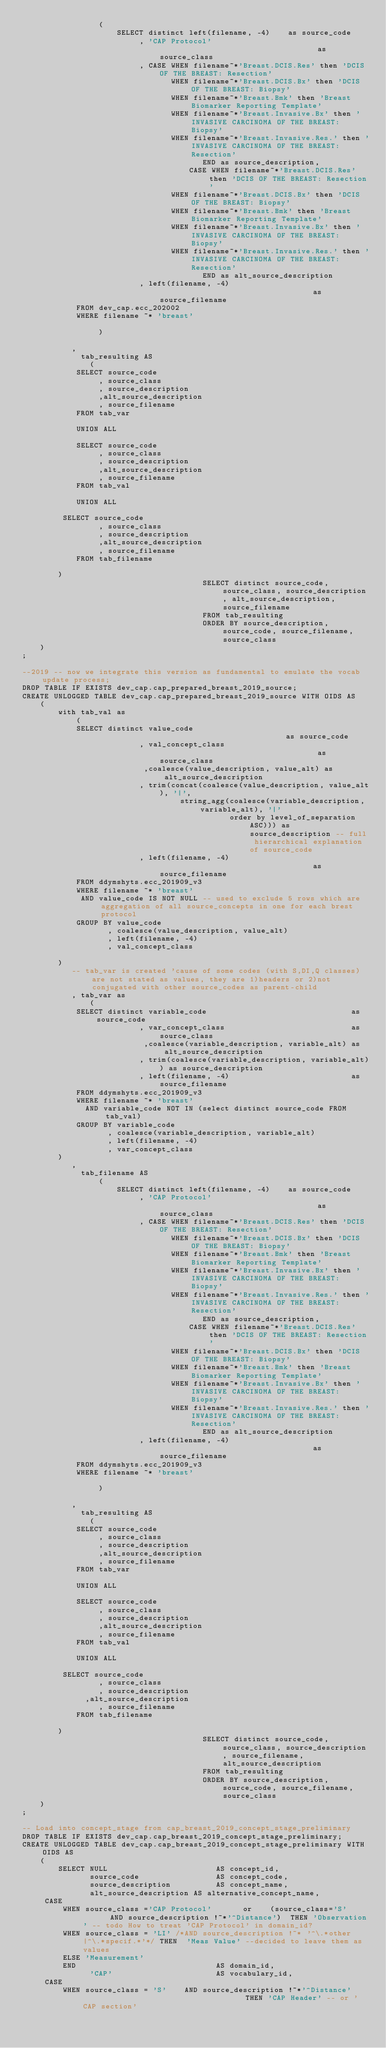Convert code to text. <code><loc_0><loc_0><loc_500><loc_500><_SQL_>                 (
                     SELECT distinct left(filename, -4)    as source_code
                          , 'CAP Protocol'                                    as source_class
                          , CASE WHEN filename~*'Breast.DCIS.Res' then 'DCIS OF THE BREAST: Resection'
                                 WHEN filename~*'Breast.DCIS.Bx' then 'DCIS OF THE BREAST: Biopsy'
                                 WHEN filename~*'Breast.Bmk' then 'Breast Biomarker Reporting Template'
                                 WHEN filename~*'Breast.Invasive.Bx' then 'INVASIVE CARCINOMA OF THE BREAST: Biopsy'
                                 WHEN filename~*'Breast.Invasive.Res.' then 'INVASIVE CARCINOMA OF THE BREAST: Resection'
                                        END as source_description,
                                     CASE WHEN filename~*'Breast.DCIS.Res' then 'DCIS OF THE BREAST: Resection'
                                 WHEN filename~*'Breast.DCIS.Bx' then 'DCIS OF THE BREAST: Biopsy'
                                 WHEN filename~*'Breast.Bmk' then 'Breast Biomarker Reporting Template'
                                 WHEN filename~*'Breast.Invasive.Bx' then 'INVASIVE CARCINOMA OF THE BREAST: Biopsy'
                                 WHEN filename~*'Breast.Invasive.Res.' then 'INVASIVE CARCINOMA OF THE BREAST: Resection'
                                        END as alt_source_description
                          , left(filename, -4)                                   as source_filename
            FROM dev_cap.ecc_202002
            WHERE filename ~* 'breast'

                 )

           ,
             tab_resulting AS
               (
            SELECT source_code
                 , source_class
                 , source_description
                 ,alt_source_description
                 , source_filename
            FROM tab_var

            UNION ALL

            SELECT source_code
                 , source_class
                 , source_description
                 ,alt_source_description
                 , source_filename
            FROM tab_val

            UNION ALL

         SELECT source_code
                 , source_class
                 , source_description
                 ,alt_source_description
                 , source_filename
            FROM tab_filename

        )
                                        SELECT distinct source_code, source_class, source_description, alt_source_description, source_filename
                                        FROM tab_resulting
                                        ORDER BY source_description, source_code, source_filename, source_class
    )
;

--2019 -- now we integrate this version as fundamental to emulate the vocab update process;
DROP TABLE IF EXISTS dev_cap.cap_prepared_breast_2019_source;
CREATE UNLOGGED TABLE dev_cap.cap_prepared_breast_2019_source WITH OIDS AS
    (
        with tab_val as
            (
            SELECT distinct value_code                                           as source_code
                          , val_concept_class                                    as source_class
                           ,coalesce(value_description, value_alt) as  alt_source_description
                          , trim(concat(coalesce(value_description, value_alt), '|',
                                   string_agg(coalesce(variable_description, variable_alt), '|'
                                              order by level_of_separation ASC))) as source_description -- full hierarchical explanation of source_code
                          , left(filename, -4)                                   as source_filename
            FROM ddymshyts.ecc_201909_v3
            WHERE filename ~* 'breast'
             AND value_code IS NOT NULL -- used to exclude 5 rows which are aggregation of all source_concepts in one for each brest protocol
            GROUP BY value_code
                   , coalesce(value_description, value_alt)
                   , left(filename, -4)
                   , val_concept_class

        )
           -- tab_var is created 'cause of some codes (with S,DI,Q classes) are not stated as values, they are 1)headers or 2)not conjugated with other source_codes as parent-child
           , tab_var as
               (
            SELECT distinct variable_code                                as source_code
                          , var_concept_class                            as source_class
                           ,coalesce(variable_description, variable_alt) as  alt_source_description
                          , trim(coalesce(variable_description, variable_alt)) as source_description
                          , left(filename, -4)                           as source_filename
            FROM ddymshyts.ecc_201909_v3
            WHERE filename ~* 'breast'
              AND variable_code NOT IN (select distinct source_code FROM tab_val)
            GROUP BY variable_code
                   , coalesce(variable_description, variable_alt)
                   , left(filename, -4)
                   , var_concept_class
        )
           ,
             tab_filename AS
                 (
                     SELECT distinct left(filename, -4)    as source_code
                          , 'CAP Protocol'                                    as source_class
                          , CASE WHEN filename~*'Breast.DCIS.Res' then 'DCIS OF THE BREAST: Resection'
                                 WHEN filename~*'Breast.DCIS.Bx' then 'DCIS OF THE BREAST: Biopsy'
                                 WHEN filename~*'Breast.Bmk' then 'Breast Biomarker Reporting Template'
                                 WHEN filename~*'Breast.Invasive.Bx' then 'INVASIVE CARCINOMA OF THE BREAST: Biopsy'
                                 WHEN filename~*'Breast.Invasive.Res.' then 'INVASIVE CARCINOMA OF THE BREAST: Resection'
                                        END as source_description,
                                     CASE WHEN filename~*'Breast.DCIS.Res' then 'DCIS OF THE BREAST: Resection'
                                 WHEN filename~*'Breast.DCIS.Bx' then 'DCIS OF THE BREAST: Biopsy'
                                 WHEN filename~*'Breast.Bmk' then 'Breast Biomarker Reporting Template'
                                 WHEN filename~*'Breast.Invasive.Bx' then 'INVASIVE CARCINOMA OF THE BREAST: Biopsy'
                                 WHEN filename~*'Breast.Invasive.Res.' then 'INVASIVE CARCINOMA OF THE BREAST: Resection'
                                        END as alt_source_description
                          , left(filename, -4)                                   as source_filename
            FROM ddymshyts.ecc_201909_v3
            WHERE filename ~* 'breast'

                 )

           ,
             tab_resulting AS
               (
            SELECT source_code
                 , source_class
                 , source_description
                 ,alt_source_description
                 , source_filename
            FROM tab_var

            UNION ALL

            SELECT source_code
                 , source_class
                 , source_description
                 ,alt_source_description
                 , source_filename
            FROM tab_val

            UNION ALL

         SELECT source_code
                 , source_class
                 , source_description
              ,alt_source_description
                 , source_filename
            FROM tab_filename

        )
                                        SELECT distinct source_code, source_class, source_description, source_filename,alt_source_description
                                        FROM tab_resulting
                                        ORDER BY source_description, source_code, source_filename, source_class
    )
;

-- Load into concept_stage from cap_breast_2019_concept_stage_preliminary
DROP TABLE IF EXISTS dev_cap.cap_breast_2019_concept_stage_preliminary;
CREATE UNLOGGED TABLE dev_cap.cap_breast_2019_concept_stage_preliminary WITH OIDS AS
    (
        SELECT NULL                        AS concept_id,
               source_code                 AS concept_code,
               source_description          AS concept_name,
               alt_source_description AS alternative_concept_name,
     CASE
         WHEN source_class ='CAP Protocol'       or    (source_class='S'       AND source_description !~*'^Distance')  THEN 'Observation' -- todo How to treat 'CAP Protocol' in domain_id?
         WHEN source_class = 'LI' /*AND source_description !~* '^\.*other|^\.*specif.*'*/ THEN  'Meas Value' --decided to leave them as values
         ELSE 'Measurement'
         END                               AS domain_id,
               'CAP'                       AS vocabulary_id,
     CASE
         WHEN source_class = 'S'    AND source_description !~*'^Distance'                                     THEN 'CAP Header' -- or 'CAP section'</code> 